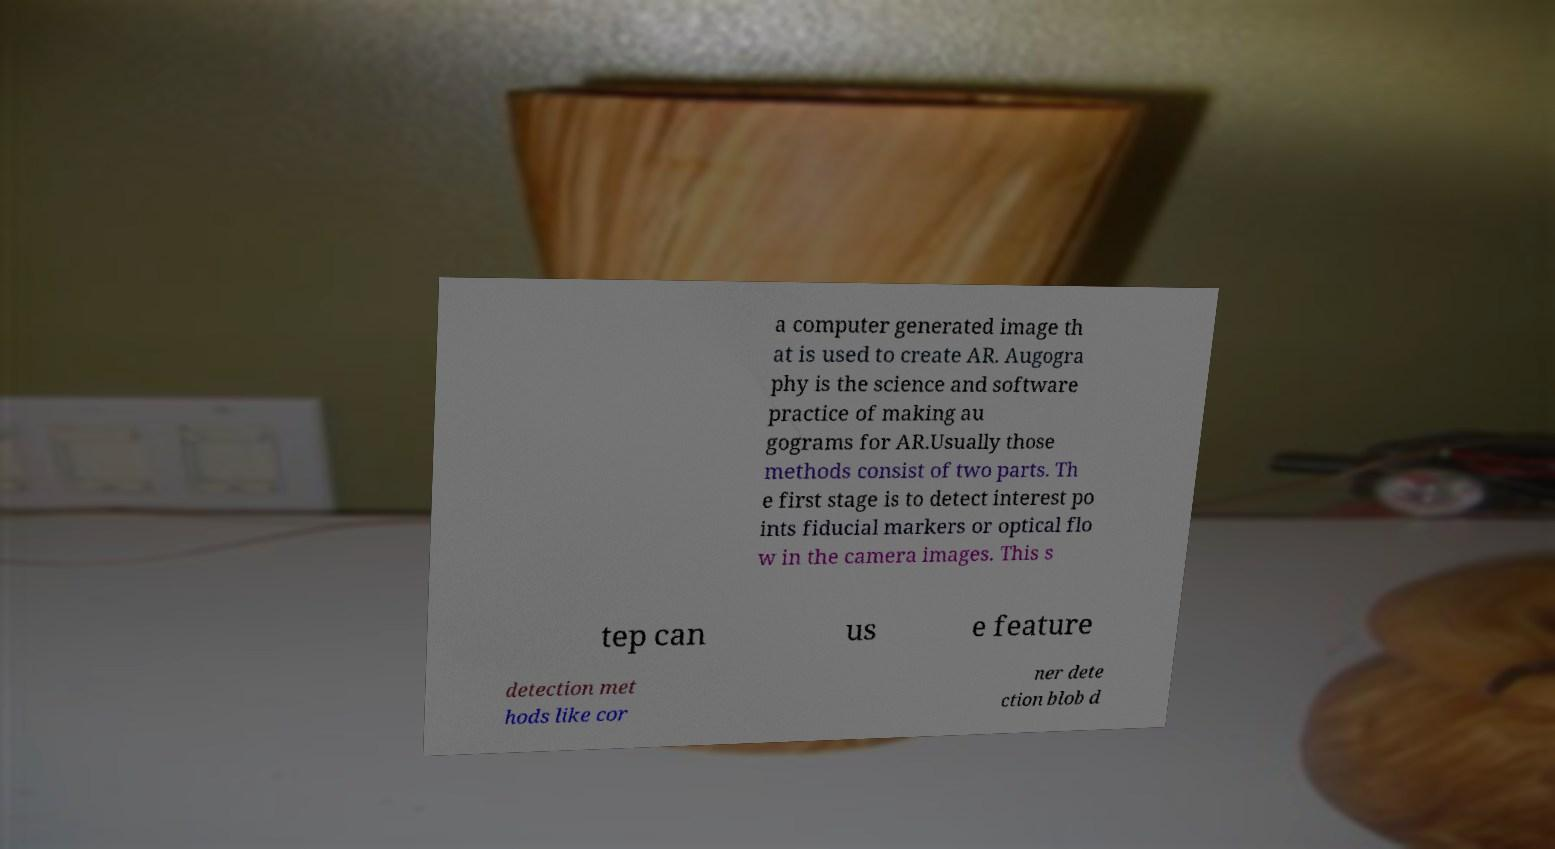What messages or text are displayed in this image? I need them in a readable, typed format. a computer generated image th at is used to create AR. Augogra phy is the science and software practice of making au gograms for AR.Usually those methods consist of two parts. Th e first stage is to detect interest po ints fiducial markers or optical flo w in the camera images. This s tep can us e feature detection met hods like cor ner dete ction blob d 